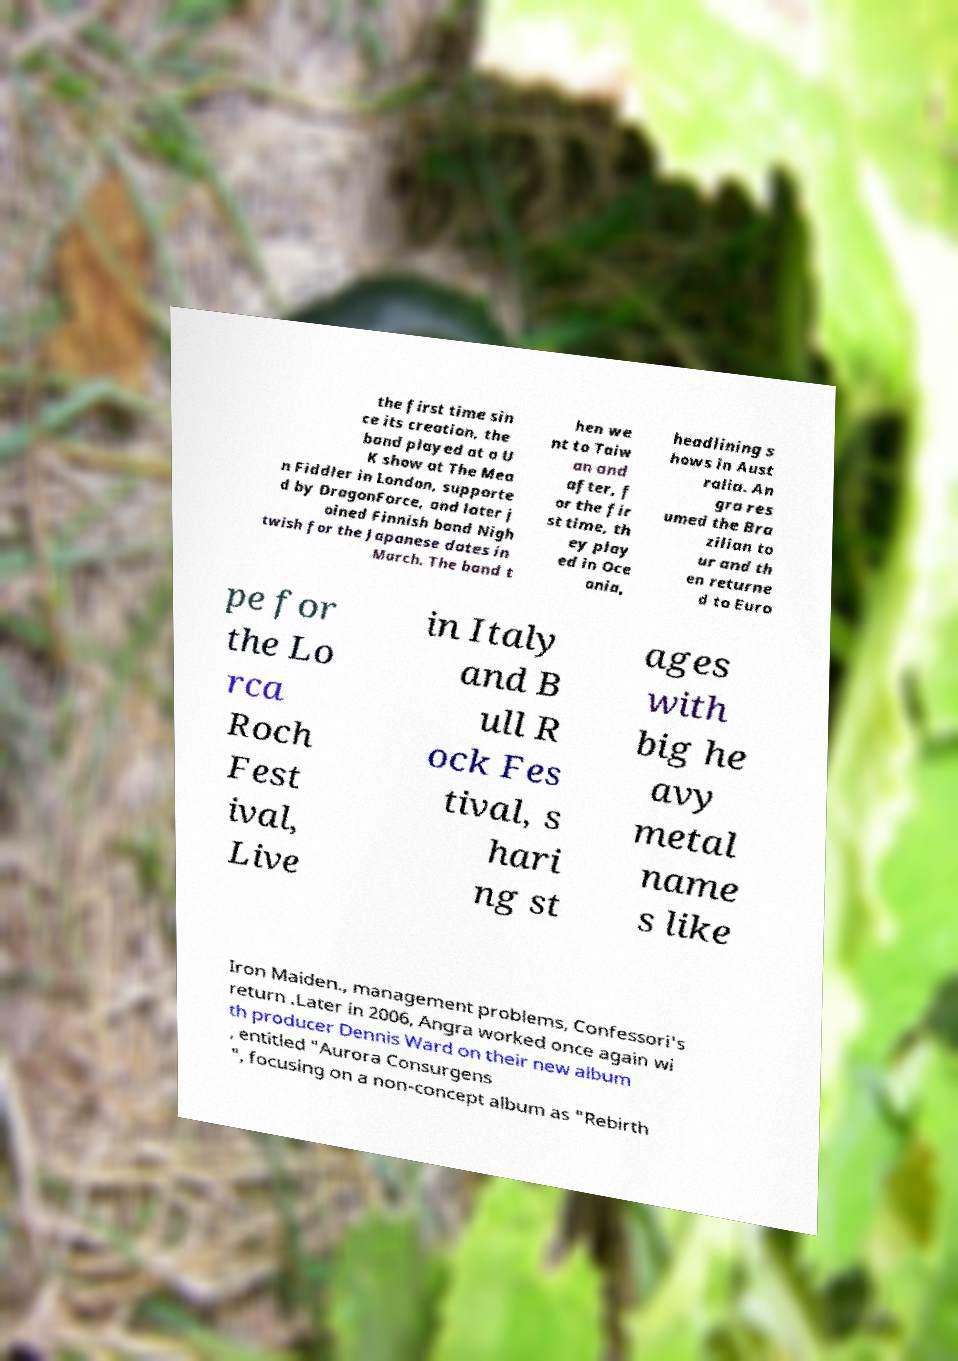For documentation purposes, I need the text within this image transcribed. Could you provide that? the first time sin ce its creation, the band played at a U K show at The Mea n Fiddler in London, supporte d by DragonForce, and later j oined Finnish band Nigh twish for the Japanese dates in March. The band t hen we nt to Taiw an and after, f or the fir st time, th ey play ed in Oce ania, headlining s hows in Aust ralia. An gra res umed the Bra zilian to ur and th en returne d to Euro pe for the Lo rca Roch Fest ival, Live in Italy and B ull R ock Fes tival, s hari ng st ages with big he avy metal name s like Iron Maiden., management problems, Confessori's return .Later in 2006, Angra worked once again wi th producer Dennis Ward on their new album , entitled "Aurora Consurgens ", focusing on a non-concept album as "Rebirth 